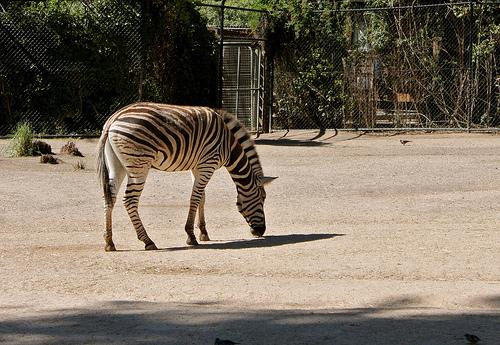What is the main focus of the image, and what is it doing presently? The main focus of the image is a zebra, which is presently sniffing the ground on gravel. Please provide a concise description of the central figure in the image and include details about their actions. The central figure in the image is a zebra that is actively sniffing the ground while standing on gravel. Can you tell me what the most prominent animal in the picture is and what action it is performing? The most prominent animal is a zebra, and it is sniffing the ground. Could you describe the primary subject of the picture briefly and mention their ongoing action? The primary subject of the picture is a zebra, and it is in the middle of sniffing the ground. In a single sentence, identify the primary entity in the image and specify what they are engaged in. The primary entity is a zebra that is engaged in sniffing the ground while standing on gravel. Write a short sentence describing the primary subject in the image and their actions. The zebra is the primary subject, and it is currently sniffing the ground. Tell me what the main subject in the image is and what they are doing at the moment. The main subject in the image is a zebra, and it is currently engaged in sniffing the ground while standing on gravel. Mention the main character of the image and describe their current posture/actions. The main character is a zebra, which is depicted sniffing the ground as it stands on gravel. Provide a brief description of the central figure in the image and mention their activity. A zebra is sniffing the ground while standing on gravel in the image. Describe the most significant object/animal in the photograph along with their current activity. The most significant animal in the photograph is a zebra that is sniffing the ground as it stands on gravel. 